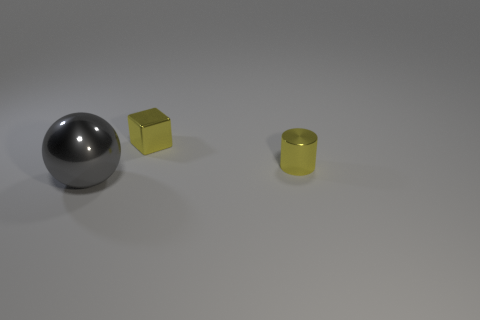Add 3 small cylinders. How many objects exist? 6 Subtract all blocks. How many objects are left? 2 Add 3 gray spheres. How many gray spheres exist? 4 Subtract 0 gray cylinders. How many objects are left? 3 Subtract all big yellow spheres. Subtract all yellow objects. How many objects are left? 1 Add 1 small yellow metal cylinders. How many small yellow metal cylinders are left? 2 